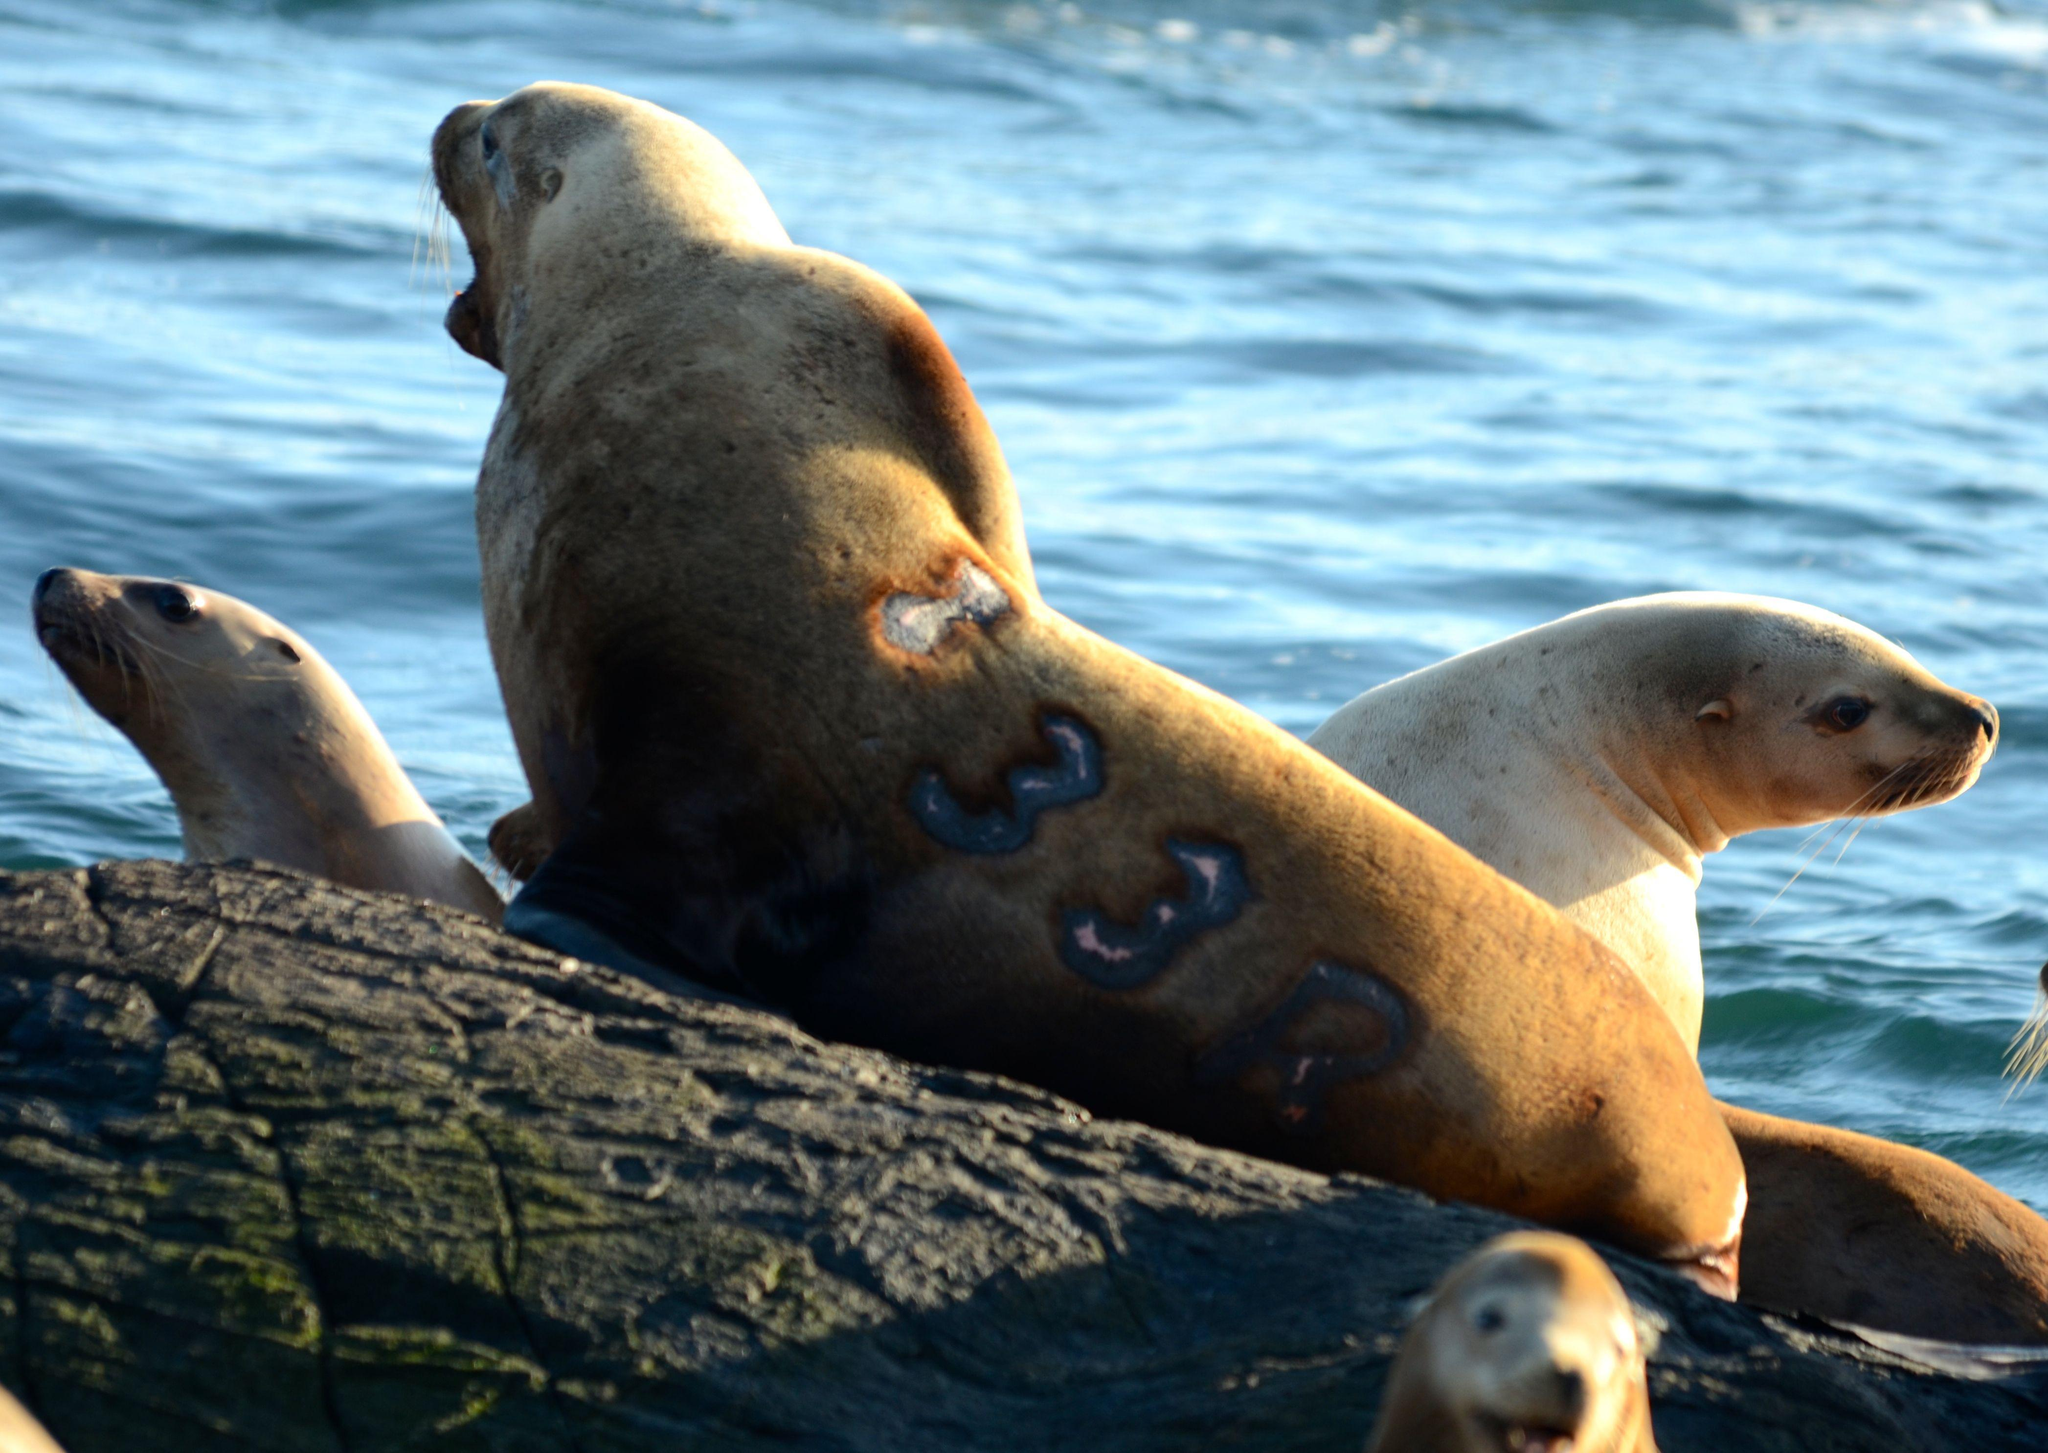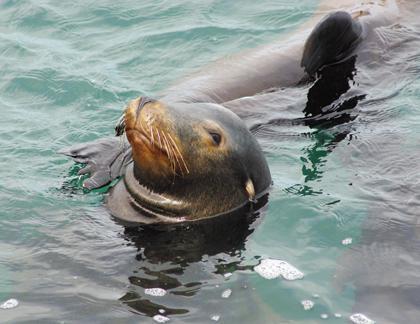The first image is the image on the left, the second image is the image on the right. Given the left and right images, does the statement "One image includes a close-mouthed seal with its face poking up out of the water, and the other image includes multiple seals at the edge of water." hold true? Answer yes or no. Yes. The first image is the image on the left, the second image is the image on the right. For the images displayed, is the sentence "The seals in the image on the right are sunning on a rock." factually correct? Answer yes or no. No. 